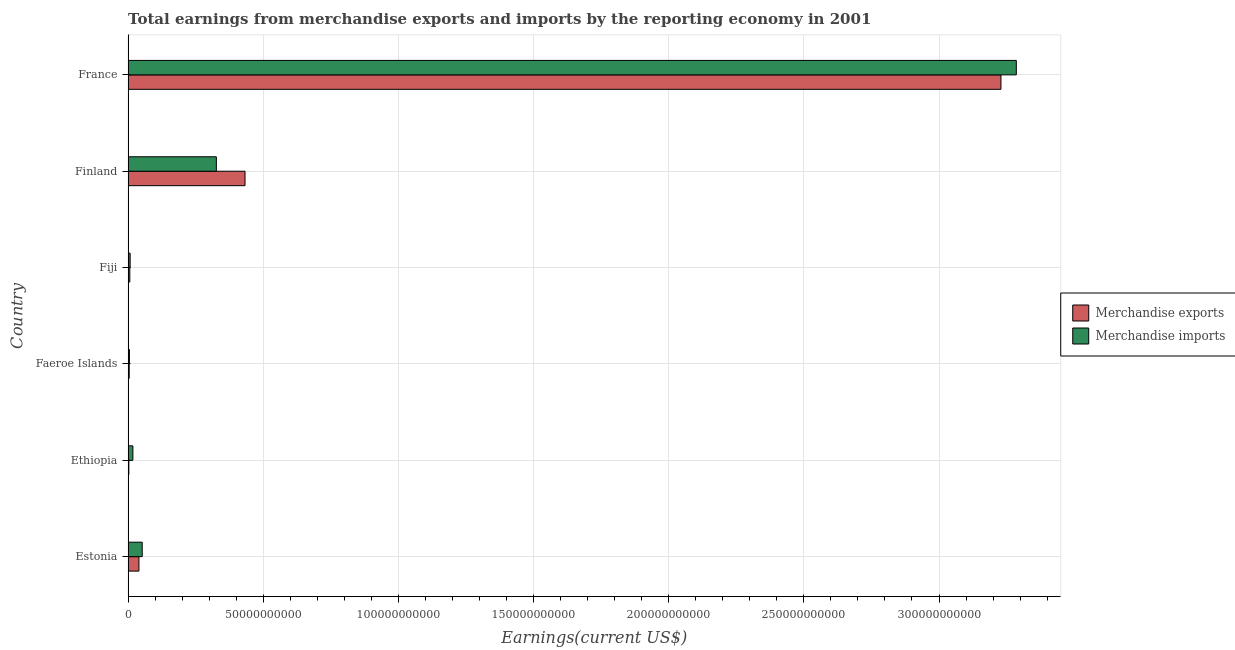How many different coloured bars are there?
Make the answer very short. 2. Are the number of bars per tick equal to the number of legend labels?
Provide a succinct answer. Yes. How many bars are there on the 3rd tick from the bottom?
Your answer should be very brief. 2. What is the label of the 6th group of bars from the top?
Provide a short and direct response. Estonia. What is the earnings from merchandise imports in Faeroe Islands?
Provide a succinct answer. 5.09e+08. Across all countries, what is the maximum earnings from merchandise exports?
Offer a terse response. 3.23e+11. Across all countries, what is the minimum earnings from merchandise imports?
Provide a succinct answer. 5.09e+08. In which country was the earnings from merchandise exports maximum?
Provide a short and direct response. France. In which country was the earnings from merchandise imports minimum?
Your response must be concise. Faeroe Islands. What is the total earnings from merchandise imports in the graph?
Offer a terse response. 3.70e+11. What is the difference between the earnings from merchandise exports in Fiji and that in France?
Give a very brief answer. -3.22e+11. What is the difference between the earnings from merchandise imports in Fiji and the earnings from merchandise exports in Finland?
Offer a very short reply. -4.25e+1. What is the average earnings from merchandise exports per country?
Give a very brief answer. 6.19e+1. What is the difference between the earnings from merchandise exports and earnings from merchandise imports in Ethiopia?
Make the answer very short. -1.50e+09. What is the ratio of the earnings from merchandise imports in Finland to that in France?
Make the answer very short. 0.1. Is the earnings from merchandise exports in Estonia less than that in Ethiopia?
Provide a succinct answer. No. What is the difference between the highest and the second highest earnings from merchandise imports?
Your answer should be very brief. 2.96e+11. What is the difference between the highest and the lowest earnings from merchandise exports?
Your response must be concise. 3.23e+11. Is the sum of the earnings from merchandise imports in Estonia and Finland greater than the maximum earnings from merchandise exports across all countries?
Ensure brevity in your answer.  No. How many bars are there?
Make the answer very short. 12. Are all the bars in the graph horizontal?
Provide a succinct answer. Yes. Are the values on the major ticks of X-axis written in scientific E-notation?
Your answer should be very brief. No. Does the graph contain any zero values?
Keep it short and to the point. No. Does the graph contain grids?
Your answer should be compact. Yes. How many legend labels are there?
Your answer should be very brief. 2. What is the title of the graph?
Your answer should be compact. Total earnings from merchandise exports and imports by the reporting economy in 2001. Does "% of gross capital formation" appear as one of the legend labels in the graph?
Your answer should be compact. No. What is the label or title of the X-axis?
Give a very brief answer. Earnings(current US$). What is the Earnings(current US$) of Merchandise exports in Estonia?
Ensure brevity in your answer.  4.02e+09. What is the Earnings(current US$) in Merchandise imports in Estonia?
Give a very brief answer. 5.23e+09. What is the Earnings(current US$) in Merchandise exports in Ethiopia?
Provide a short and direct response. 2.86e+08. What is the Earnings(current US$) in Merchandise imports in Ethiopia?
Your answer should be very brief. 1.78e+09. What is the Earnings(current US$) of Merchandise exports in Faeroe Islands?
Ensure brevity in your answer.  4.24e+08. What is the Earnings(current US$) of Merchandise imports in Faeroe Islands?
Keep it short and to the point. 5.09e+08. What is the Earnings(current US$) in Merchandise exports in Fiji?
Provide a succinct answer. 6.40e+08. What is the Earnings(current US$) in Merchandise imports in Fiji?
Your answer should be compact. 7.64e+08. What is the Earnings(current US$) in Merchandise exports in Finland?
Provide a succinct answer. 4.33e+1. What is the Earnings(current US$) in Merchandise imports in Finland?
Keep it short and to the point. 3.27e+1. What is the Earnings(current US$) of Merchandise exports in France?
Provide a succinct answer. 3.23e+11. What is the Earnings(current US$) of Merchandise imports in France?
Offer a very short reply. 3.29e+11. Across all countries, what is the maximum Earnings(current US$) of Merchandise exports?
Your response must be concise. 3.23e+11. Across all countries, what is the maximum Earnings(current US$) of Merchandise imports?
Your answer should be very brief. 3.29e+11. Across all countries, what is the minimum Earnings(current US$) in Merchandise exports?
Offer a terse response. 2.86e+08. Across all countries, what is the minimum Earnings(current US$) in Merchandise imports?
Your answer should be compact. 5.09e+08. What is the total Earnings(current US$) of Merchandise exports in the graph?
Offer a terse response. 3.72e+11. What is the total Earnings(current US$) in Merchandise imports in the graph?
Make the answer very short. 3.70e+11. What is the difference between the Earnings(current US$) in Merchandise exports in Estonia and that in Ethiopia?
Keep it short and to the point. 3.73e+09. What is the difference between the Earnings(current US$) in Merchandise imports in Estonia and that in Ethiopia?
Offer a very short reply. 3.45e+09. What is the difference between the Earnings(current US$) in Merchandise exports in Estonia and that in Faeroe Islands?
Keep it short and to the point. 3.59e+09. What is the difference between the Earnings(current US$) of Merchandise imports in Estonia and that in Faeroe Islands?
Make the answer very short. 4.72e+09. What is the difference between the Earnings(current US$) of Merchandise exports in Estonia and that in Fiji?
Provide a short and direct response. 3.38e+09. What is the difference between the Earnings(current US$) of Merchandise imports in Estonia and that in Fiji?
Ensure brevity in your answer.  4.47e+09. What is the difference between the Earnings(current US$) in Merchandise exports in Estonia and that in Finland?
Keep it short and to the point. -3.92e+1. What is the difference between the Earnings(current US$) in Merchandise imports in Estonia and that in Finland?
Offer a terse response. -2.74e+1. What is the difference between the Earnings(current US$) of Merchandise exports in Estonia and that in France?
Make the answer very short. -3.19e+11. What is the difference between the Earnings(current US$) in Merchandise imports in Estonia and that in France?
Keep it short and to the point. -3.23e+11. What is the difference between the Earnings(current US$) of Merchandise exports in Ethiopia and that in Faeroe Islands?
Ensure brevity in your answer.  -1.38e+08. What is the difference between the Earnings(current US$) of Merchandise imports in Ethiopia and that in Faeroe Islands?
Ensure brevity in your answer.  1.27e+09. What is the difference between the Earnings(current US$) of Merchandise exports in Ethiopia and that in Fiji?
Ensure brevity in your answer.  -3.54e+08. What is the difference between the Earnings(current US$) of Merchandise imports in Ethiopia and that in Fiji?
Ensure brevity in your answer.  1.02e+09. What is the difference between the Earnings(current US$) in Merchandise exports in Ethiopia and that in Finland?
Offer a terse response. -4.30e+1. What is the difference between the Earnings(current US$) in Merchandise imports in Ethiopia and that in Finland?
Make the answer very short. -3.09e+1. What is the difference between the Earnings(current US$) in Merchandise exports in Ethiopia and that in France?
Your response must be concise. -3.23e+11. What is the difference between the Earnings(current US$) of Merchandise imports in Ethiopia and that in France?
Make the answer very short. -3.27e+11. What is the difference between the Earnings(current US$) in Merchandise exports in Faeroe Islands and that in Fiji?
Your response must be concise. -2.16e+08. What is the difference between the Earnings(current US$) in Merchandise imports in Faeroe Islands and that in Fiji?
Your answer should be compact. -2.54e+08. What is the difference between the Earnings(current US$) in Merchandise exports in Faeroe Islands and that in Finland?
Ensure brevity in your answer.  -4.28e+1. What is the difference between the Earnings(current US$) in Merchandise imports in Faeroe Islands and that in Finland?
Your response must be concise. -3.21e+1. What is the difference between the Earnings(current US$) of Merchandise exports in Faeroe Islands and that in France?
Your answer should be compact. -3.22e+11. What is the difference between the Earnings(current US$) in Merchandise imports in Faeroe Islands and that in France?
Your response must be concise. -3.28e+11. What is the difference between the Earnings(current US$) in Merchandise exports in Fiji and that in Finland?
Your answer should be compact. -4.26e+1. What is the difference between the Earnings(current US$) in Merchandise imports in Fiji and that in Finland?
Your answer should be very brief. -3.19e+1. What is the difference between the Earnings(current US$) of Merchandise exports in Fiji and that in France?
Your answer should be very brief. -3.22e+11. What is the difference between the Earnings(current US$) in Merchandise imports in Fiji and that in France?
Provide a succinct answer. -3.28e+11. What is the difference between the Earnings(current US$) in Merchandise exports in Finland and that in France?
Offer a very short reply. -2.80e+11. What is the difference between the Earnings(current US$) in Merchandise imports in Finland and that in France?
Ensure brevity in your answer.  -2.96e+11. What is the difference between the Earnings(current US$) of Merchandise exports in Estonia and the Earnings(current US$) of Merchandise imports in Ethiopia?
Give a very brief answer. 2.24e+09. What is the difference between the Earnings(current US$) of Merchandise exports in Estonia and the Earnings(current US$) of Merchandise imports in Faeroe Islands?
Your answer should be compact. 3.51e+09. What is the difference between the Earnings(current US$) in Merchandise exports in Estonia and the Earnings(current US$) in Merchandise imports in Fiji?
Ensure brevity in your answer.  3.25e+09. What is the difference between the Earnings(current US$) in Merchandise exports in Estonia and the Earnings(current US$) in Merchandise imports in Finland?
Give a very brief answer. -2.86e+1. What is the difference between the Earnings(current US$) of Merchandise exports in Estonia and the Earnings(current US$) of Merchandise imports in France?
Your answer should be very brief. -3.25e+11. What is the difference between the Earnings(current US$) in Merchandise exports in Ethiopia and the Earnings(current US$) in Merchandise imports in Faeroe Islands?
Ensure brevity in your answer.  -2.23e+08. What is the difference between the Earnings(current US$) of Merchandise exports in Ethiopia and the Earnings(current US$) of Merchandise imports in Fiji?
Make the answer very short. -4.78e+08. What is the difference between the Earnings(current US$) in Merchandise exports in Ethiopia and the Earnings(current US$) in Merchandise imports in Finland?
Your answer should be compact. -3.24e+1. What is the difference between the Earnings(current US$) in Merchandise exports in Ethiopia and the Earnings(current US$) in Merchandise imports in France?
Offer a very short reply. -3.28e+11. What is the difference between the Earnings(current US$) in Merchandise exports in Faeroe Islands and the Earnings(current US$) in Merchandise imports in Fiji?
Provide a short and direct response. -3.40e+08. What is the difference between the Earnings(current US$) in Merchandise exports in Faeroe Islands and the Earnings(current US$) in Merchandise imports in Finland?
Your answer should be compact. -3.22e+1. What is the difference between the Earnings(current US$) of Merchandise exports in Faeroe Islands and the Earnings(current US$) of Merchandise imports in France?
Offer a terse response. -3.28e+11. What is the difference between the Earnings(current US$) of Merchandise exports in Fiji and the Earnings(current US$) of Merchandise imports in Finland?
Your response must be concise. -3.20e+1. What is the difference between the Earnings(current US$) of Merchandise exports in Fiji and the Earnings(current US$) of Merchandise imports in France?
Your answer should be very brief. -3.28e+11. What is the difference between the Earnings(current US$) in Merchandise exports in Finland and the Earnings(current US$) in Merchandise imports in France?
Your answer should be very brief. -2.85e+11. What is the average Earnings(current US$) of Merchandise exports per country?
Offer a terse response. 6.19e+1. What is the average Earnings(current US$) of Merchandise imports per country?
Provide a short and direct response. 6.16e+1. What is the difference between the Earnings(current US$) in Merchandise exports and Earnings(current US$) in Merchandise imports in Estonia?
Provide a succinct answer. -1.21e+09. What is the difference between the Earnings(current US$) of Merchandise exports and Earnings(current US$) of Merchandise imports in Ethiopia?
Your answer should be very brief. -1.50e+09. What is the difference between the Earnings(current US$) of Merchandise exports and Earnings(current US$) of Merchandise imports in Faeroe Islands?
Ensure brevity in your answer.  -8.54e+07. What is the difference between the Earnings(current US$) of Merchandise exports and Earnings(current US$) of Merchandise imports in Fiji?
Give a very brief answer. -1.24e+08. What is the difference between the Earnings(current US$) in Merchandise exports and Earnings(current US$) in Merchandise imports in Finland?
Offer a terse response. 1.06e+1. What is the difference between the Earnings(current US$) of Merchandise exports and Earnings(current US$) of Merchandise imports in France?
Your response must be concise. -5.69e+09. What is the ratio of the Earnings(current US$) of Merchandise exports in Estonia to that in Ethiopia?
Ensure brevity in your answer.  14.05. What is the ratio of the Earnings(current US$) of Merchandise imports in Estonia to that in Ethiopia?
Keep it short and to the point. 2.93. What is the ratio of the Earnings(current US$) of Merchandise exports in Estonia to that in Faeroe Islands?
Offer a very short reply. 9.48. What is the ratio of the Earnings(current US$) of Merchandise imports in Estonia to that in Faeroe Islands?
Provide a succinct answer. 10.27. What is the ratio of the Earnings(current US$) in Merchandise exports in Estonia to that in Fiji?
Provide a succinct answer. 6.28. What is the ratio of the Earnings(current US$) in Merchandise imports in Estonia to that in Fiji?
Keep it short and to the point. 6.85. What is the ratio of the Earnings(current US$) in Merchandise exports in Estonia to that in Finland?
Your answer should be compact. 0.09. What is the ratio of the Earnings(current US$) of Merchandise imports in Estonia to that in Finland?
Keep it short and to the point. 0.16. What is the ratio of the Earnings(current US$) in Merchandise exports in Estonia to that in France?
Offer a very short reply. 0.01. What is the ratio of the Earnings(current US$) of Merchandise imports in Estonia to that in France?
Ensure brevity in your answer.  0.02. What is the ratio of the Earnings(current US$) of Merchandise exports in Ethiopia to that in Faeroe Islands?
Give a very brief answer. 0.67. What is the ratio of the Earnings(current US$) in Merchandise imports in Ethiopia to that in Faeroe Islands?
Provide a succinct answer. 3.5. What is the ratio of the Earnings(current US$) in Merchandise exports in Ethiopia to that in Fiji?
Your answer should be very brief. 0.45. What is the ratio of the Earnings(current US$) of Merchandise imports in Ethiopia to that in Fiji?
Make the answer very short. 2.33. What is the ratio of the Earnings(current US$) in Merchandise exports in Ethiopia to that in Finland?
Offer a very short reply. 0.01. What is the ratio of the Earnings(current US$) in Merchandise imports in Ethiopia to that in Finland?
Offer a very short reply. 0.05. What is the ratio of the Earnings(current US$) of Merchandise exports in Ethiopia to that in France?
Ensure brevity in your answer.  0. What is the ratio of the Earnings(current US$) of Merchandise imports in Ethiopia to that in France?
Keep it short and to the point. 0.01. What is the ratio of the Earnings(current US$) of Merchandise exports in Faeroe Islands to that in Fiji?
Keep it short and to the point. 0.66. What is the ratio of the Earnings(current US$) of Merchandise imports in Faeroe Islands to that in Fiji?
Your answer should be very brief. 0.67. What is the ratio of the Earnings(current US$) of Merchandise exports in Faeroe Islands to that in Finland?
Offer a very short reply. 0.01. What is the ratio of the Earnings(current US$) of Merchandise imports in Faeroe Islands to that in Finland?
Offer a terse response. 0.02. What is the ratio of the Earnings(current US$) of Merchandise exports in Faeroe Islands to that in France?
Your response must be concise. 0. What is the ratio of the Earnings(current US$) of Merchandise imports in Faeroe Islands to that in France?
Your response must be concise. 0. What is the ratio of the Earnings(current US$) in Merchandise exports in Fiji to that in Finland?
Provide a short and direct response. 0.01. What is the ratio of the Earnings(current US$) of Merchandise imports in Fiji to that in Finland?
Give a very brief answer. 0.02. What is the ratio of the Earnings(current US$) in Merchandise exports in Fiji to that in France?
Give a very brief answer. 0. What is the ratio of the Earnings(current US$) in Merchandise imports in Fiji to that in France?
Give a very brief answer. 0. What is the ratio of the Earnings(current US$) in Merchandise exports in Finland to that in France?
Your answer should be very brief. 0.13. What is the ratio of the Earnings(current US$) in Merchandise imports in Finland to that in France?
Keep it short and to the point. 0.1. What is the difference between the highest and the second highest Earnings(current US$) of Merchandise exports?
Ensure brevity in your answer.  2.80e+11. What is the difference between the highest and the second highest Earnings(current US$) of Merchandise imports?
Make the answer very short. 2.96e+11. What is the difference between the highest and the lowest Earnings(current US$) in Merchandise exports?
Your answer should be compact. 3.23e+11. What is the difference between the highest and the lowest Earnings(current US$) in Merchandise imports?
Give a very brief answer. 3.28e+11. 